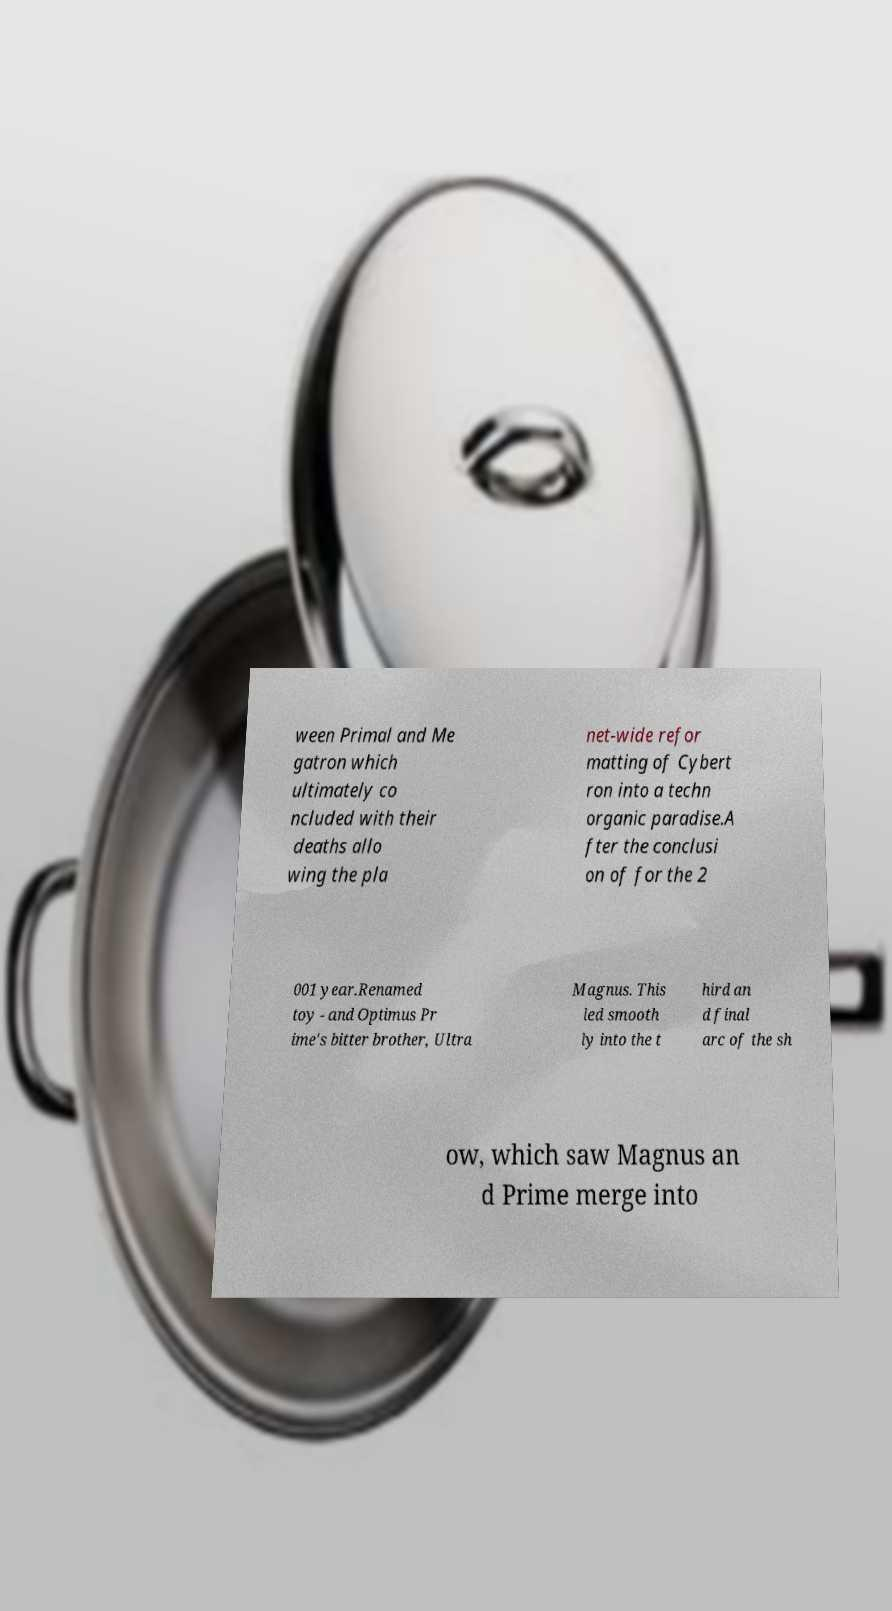What messages or text are displayed in this image? I need them in a readable, typed format. ween Primal and Me gatron which ultimately co ncluded with their deaths allo wing the pla net-wide refor matting of Cybert ron into a techn organic paradise.A fter the conclusi on of for the 2 001 year.Renamed toy - and Optimus Pr ime's bitter brother, Ultra Magnus. This led smooth ly into the t hird an d final arc of the sh ow, which saw Magnus an d Prime merge into 